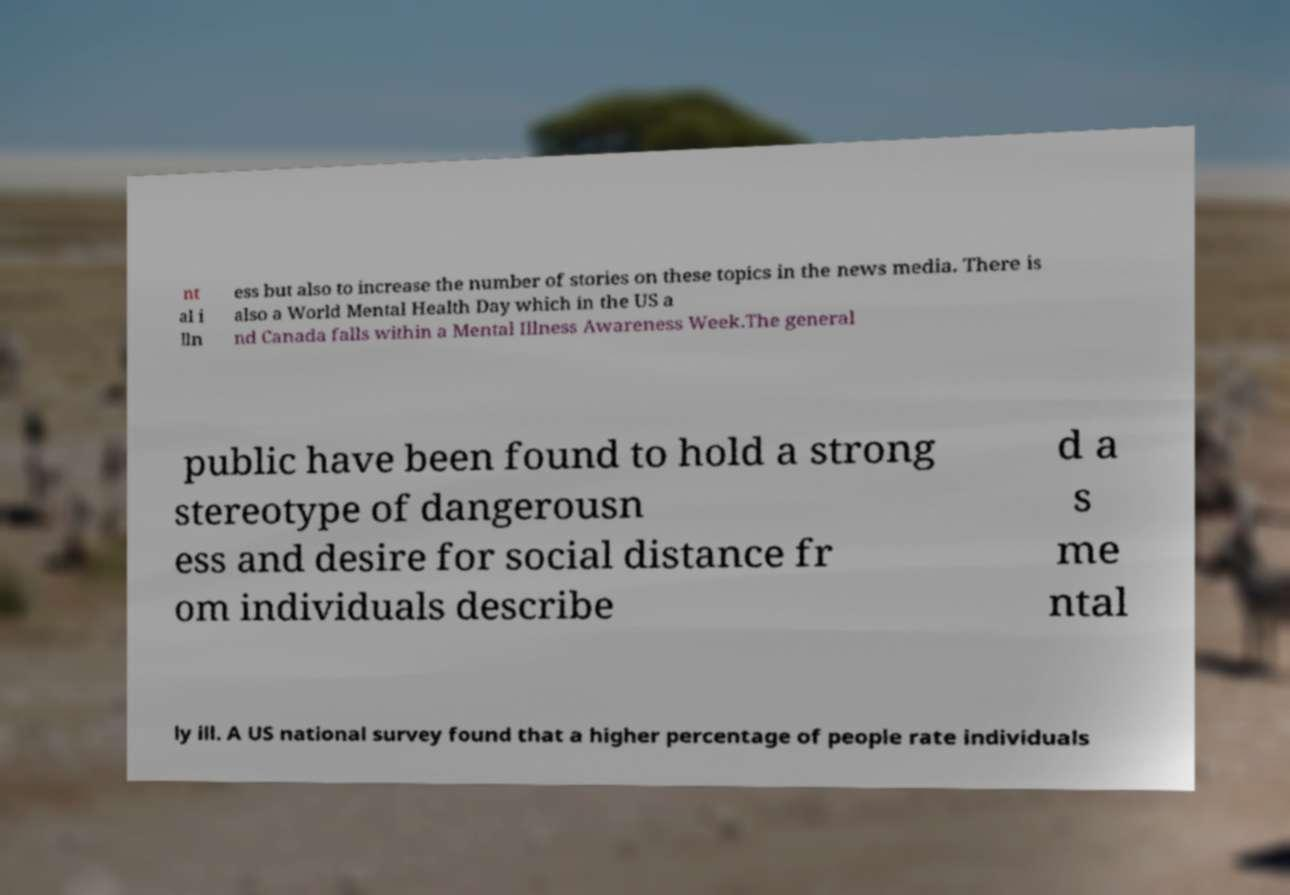Please identify and transcribe the text found in this image. nt al i lln ess but also to increase the number of stories on these topics in the news media. There is also a World Mental Health Day which in the US a nd Canada falls within a Mental Illness Awareness Week.The general public have been found to hold a strong stereotype of dangerousn ess and desire for social distance fr om individuals describe d a s me ntal ly ill. A US national survey found that a higher percentage of people rate individuals 